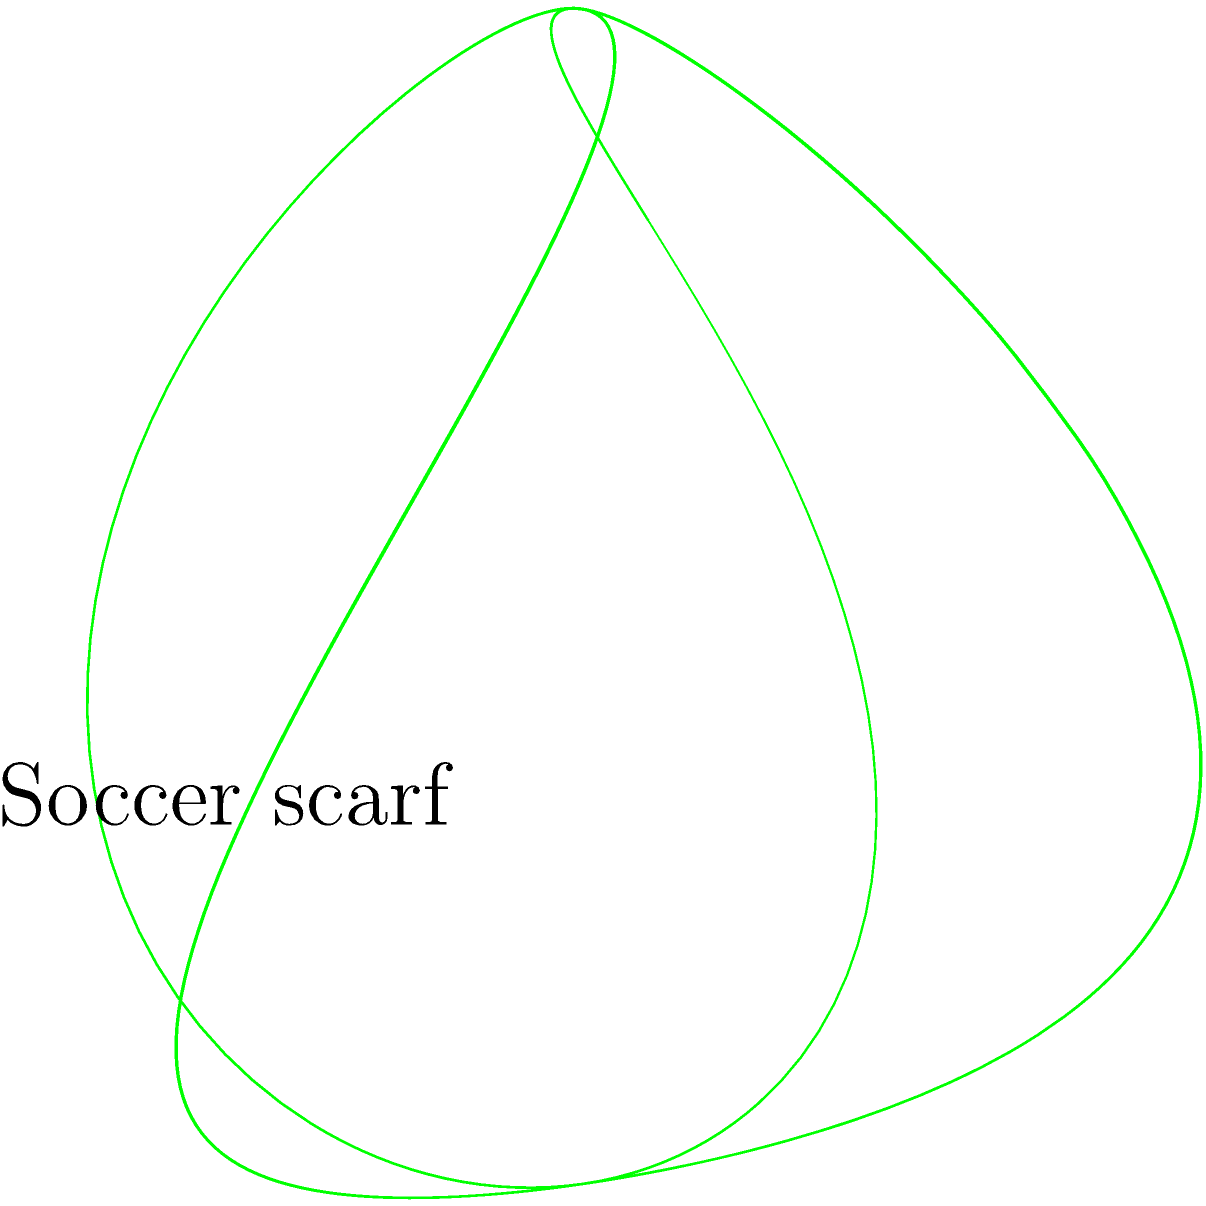A passionate soccer fan wants to create a Möbius strip using their favorite team's scarf. If they start with a rectangular scarf that is 1.5 meters long and 20 centimeters wide, what is the total surface area of the Möbius strip formed by giving the scarf a half-twist and joining the ends? Let's approach this step-by-step:

1) First, recall that a Möbius strip is a surface with only one side and one edge.

2) The formula for the surface area of a Möbius strip is:

   $$A = \frac{1}{2} \cdot l \cdot w$$

   Where $l$ is the length of the strip and $w$ is the width.

3) We are given:
   - Length (l) = 1.5 meters = 150 cm
   - Width (w) = 20 cm

4) Let's substitute these values into our formula:

   $$A = \frac{1}{2} \cdot 150 \cdot 20$$

5) Now, let's calculate:

   $$A = \frac{1}{2} \cdot 3000 = 1500$$

6) Therefore, the surface area is 1500 square centimeters.

7) Converting to square meters:
   
   $$1500 \text{ cm}^2 = 0.15 \text{ m}^2$$

So, the total surface area of the Möbius strip formed by the scarf is 0.15 square meters.
Answer: 0.15 m² 